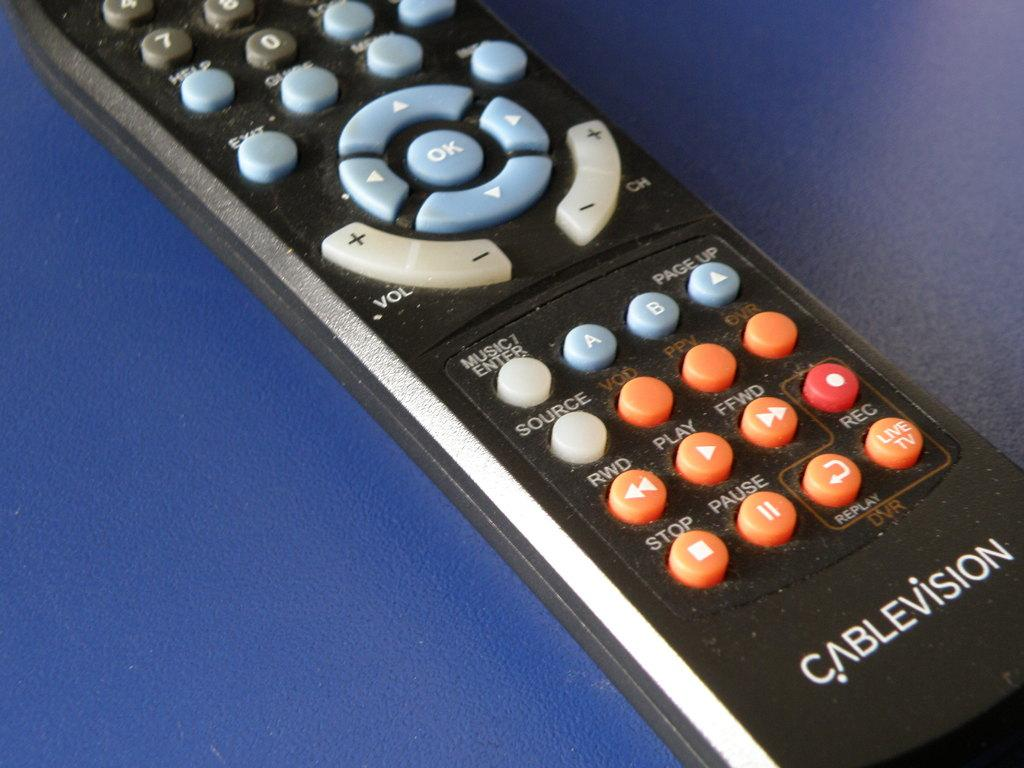<image>
Offer a succinct explanation of the picture presented. The hand held remote for a Cablevision tuner. 